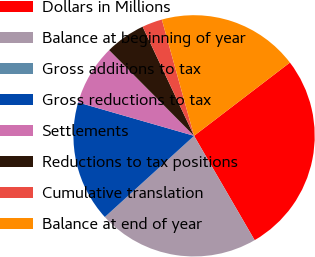<chart> <loc_0><loc_0><loc_500><loc_500><pie_chart><fcel>Dollars in Millions<fcel>Balance at beginning of year<fcel>Gross additions to tax<fcel>Gross reductions to tax<fcel>Settlements<fcel>Reductions to tax positions<fcel>Cumulative translation<fcel>Balance at end of year<nl><fcel>27.01%<fcel>21.61%<fcel>0.01%<fcel>16.21%<fcel>8.11%<fcel>5.41%<fcel>2.71%<fcel>18.91%<nl></chart> 